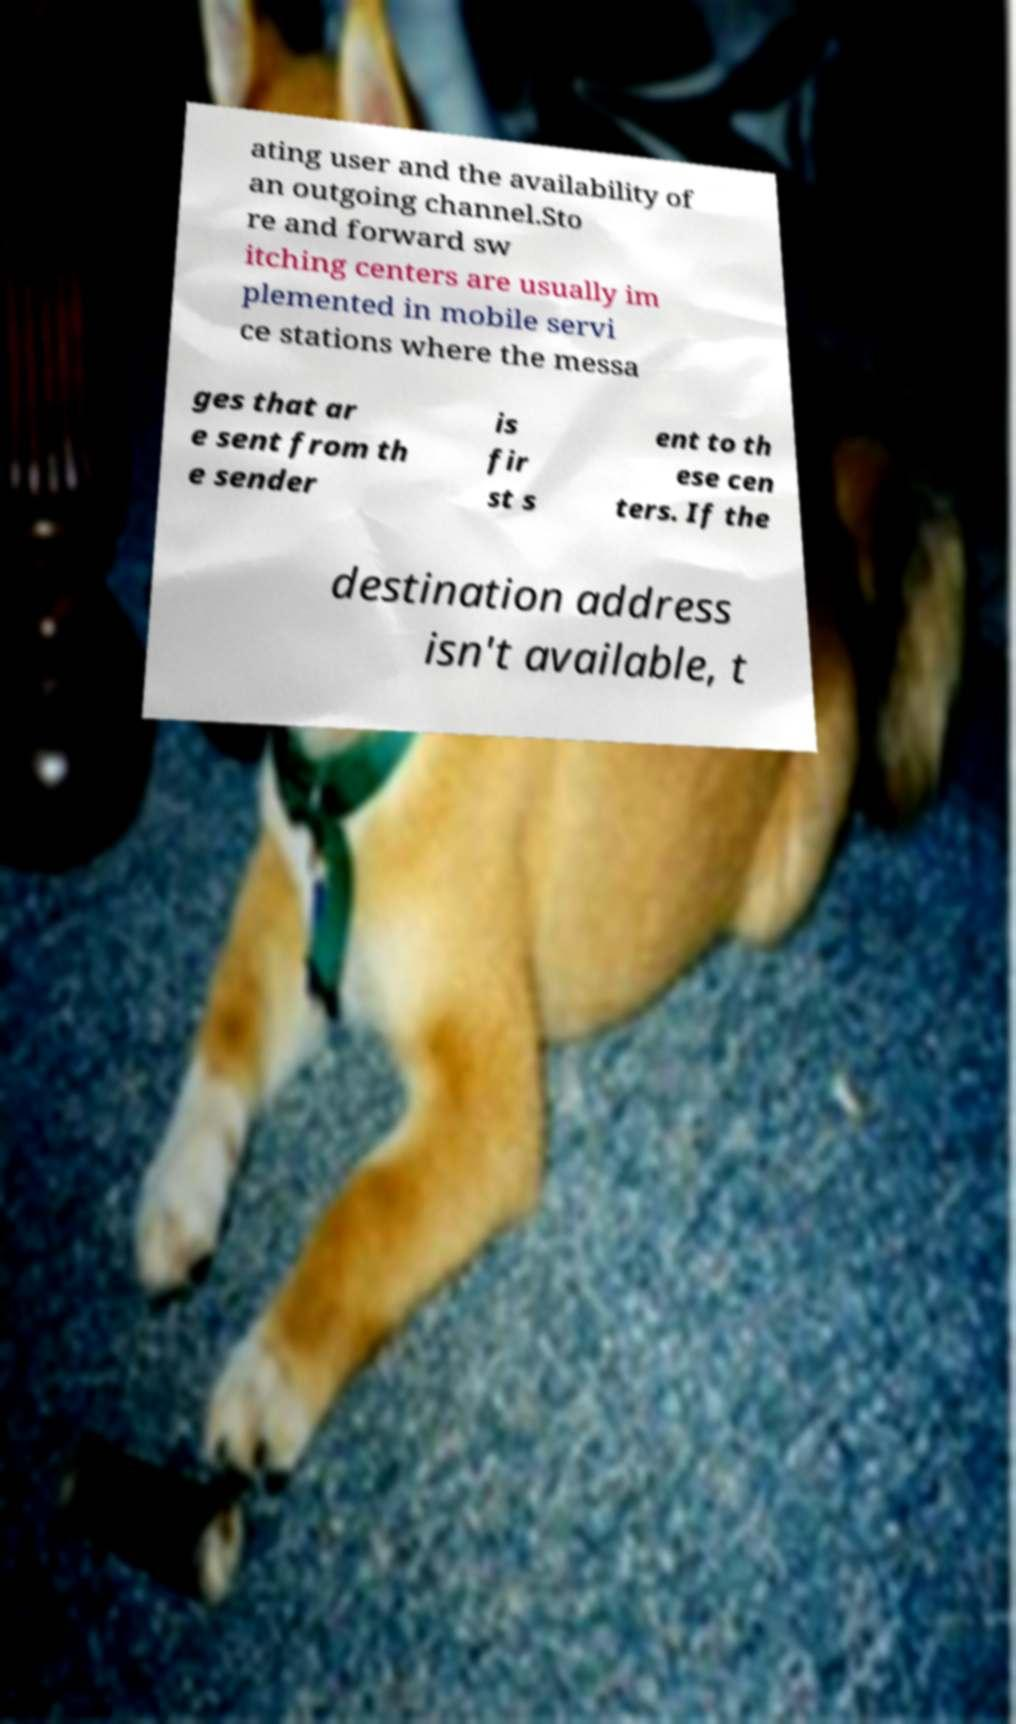Can you accurately transcribe the text from the provided image for me? ating user and the availability of an outgoing channel.Sto re and forward sw itching centers are usually im plemented in mobile servi ce stations where the messa ges that ar e sent from th e sender is fir st s ent to th ese cen ters. If the destination address isn't available, t 